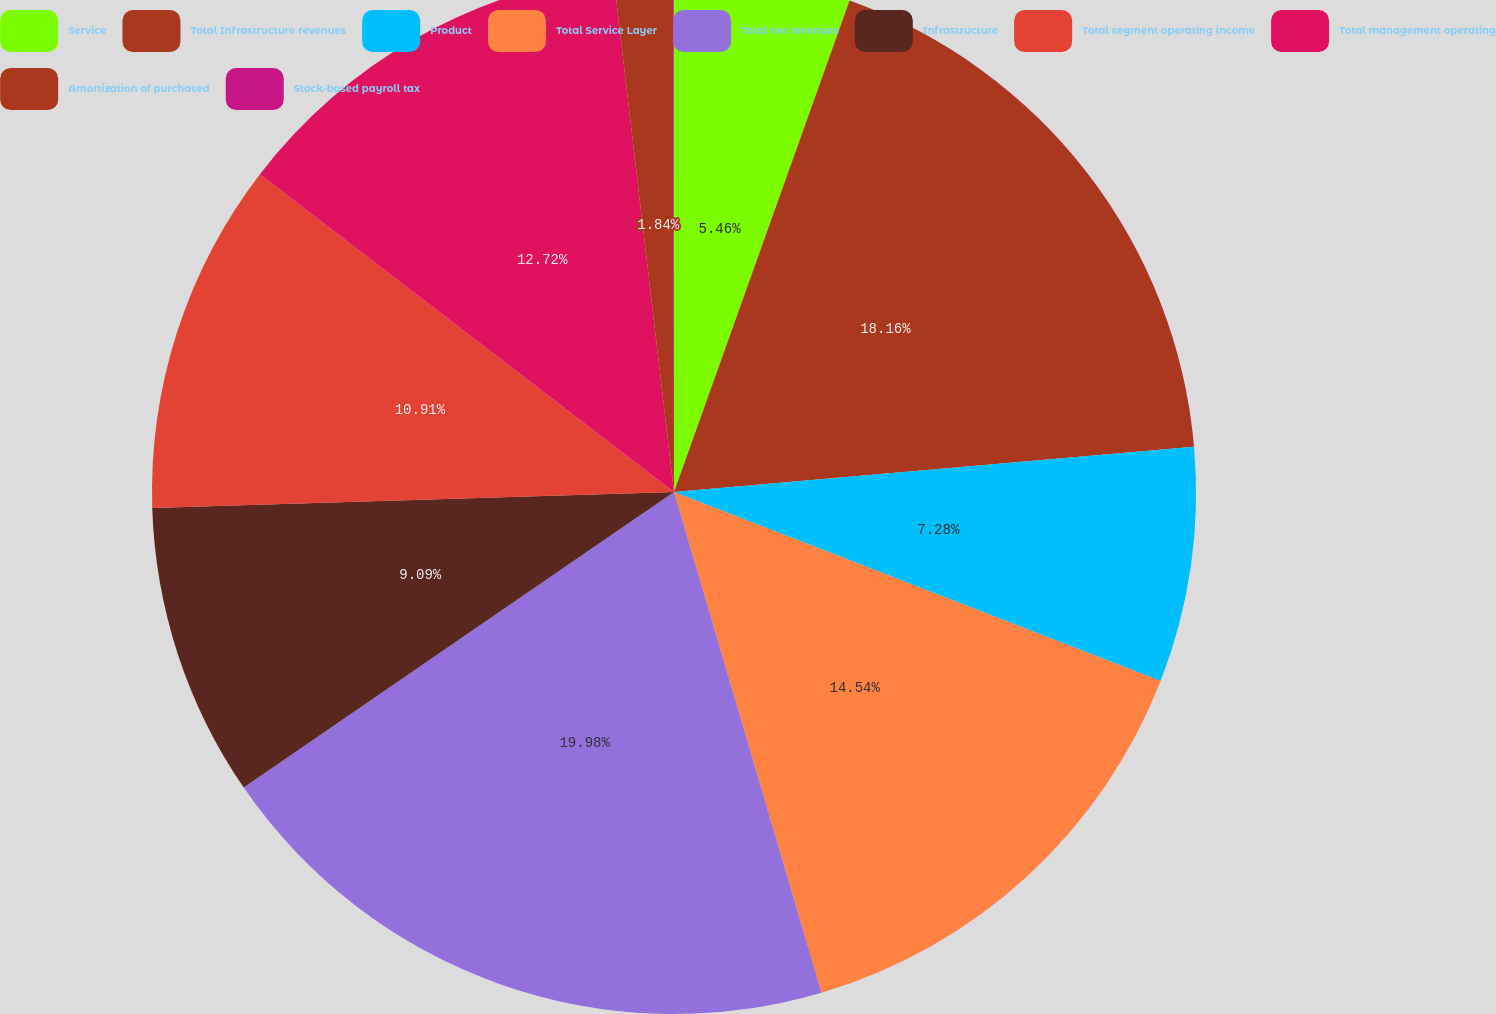<chart> <loc_0><loc_0><loc_500><loc_500><pie_chart><fcel>Service<fcel>Total Infrastructure revenues<fcel>Product<fcel>Total Service Layer<fcel>Total net revenues<fcel>Infrastructure<fcel>Total segment operating income<fcel>Total management operating<fcel>Amortization of purchased<fcel>Stock-based payroll tax<nl><fcel>5.46%<fcel>18.16%<fcel>7.28%<fcel>14.54%<fcel>19.98%<fcel>9.09%<fcel>10.91%<fcel>12.72%<fcel>1.84%<fcel>0.02%<nl></chart> 